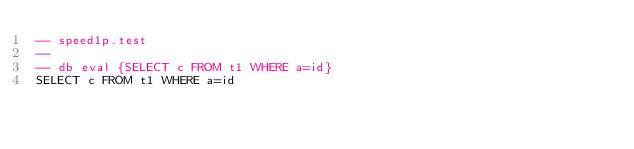<code> <loc_0><loc_0><loc_500><loc_500><_SQL_>-- speed1p.test
-- 
-- db eval {SELECT c FROM t1 WHERE a=id}
SELECT c FROM t1 WHERE a=id
</code> 